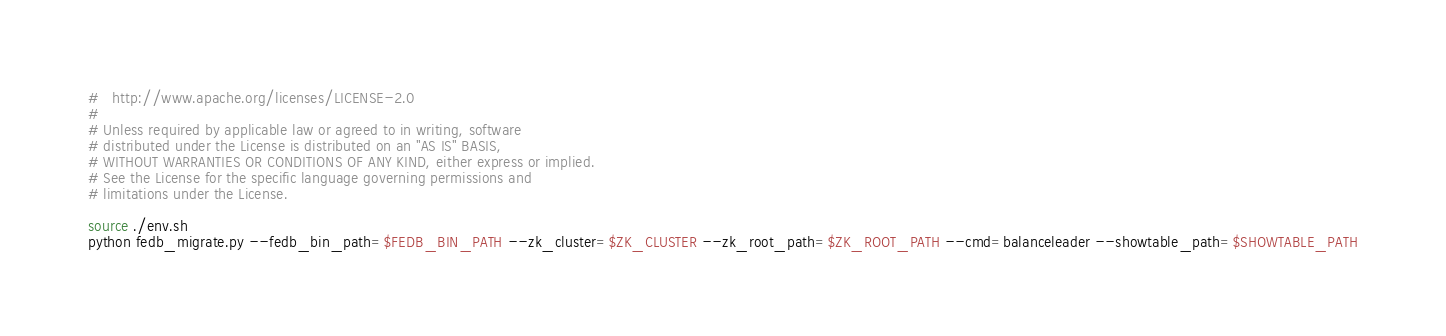Convert code to text. <code><loc_0><loc_0><loc_500><loc_500><_Bash_>#   http://www.apache.org/licenses/LICENSE-2.0
#
# Unless required by applicable law or agreed to in writing, software
# distributed under the License is distributed on an "AS IS" BASIS,
# WITHOUT WARRANTIES OR CONDITIONS OF ANY KIND, either express or implied.
# See the License for the specific language governing permissions and
# limitations under the License.

source ./env.sh
python fedb_migrate.py --fedb_bin_path=$FEDB_BIN_PATH --zk_cluster=$ZK_CLUSTER --zk_root_path=$ZK_ROOT_PATH --cmd=balanceleader --showtable_path=$SHOWTABLE_PATH
</code> 